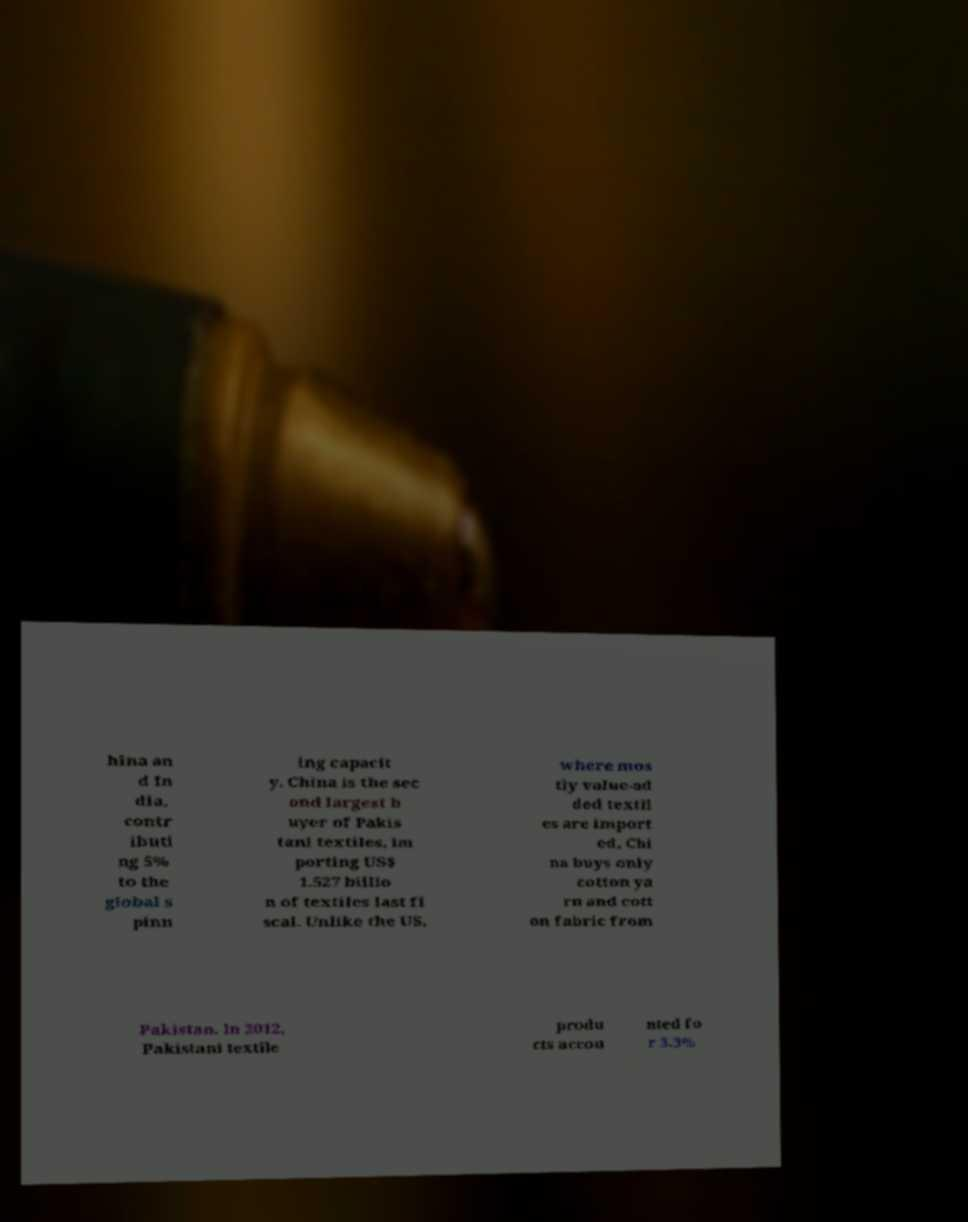There's text embedded in this image that I need extracted. Can you transcribe it verbatim? hina an d In dia, contr ibuti ng 5% to the global s pinn ing capacit y. China is the sec ond largest b uyer of Pakis tani textiles, im porting US$ 1.527 billio n of textiles last fi scal. Unlike the US, where mos tly value-ad ded textil es are import ed, Chi na buys only cotton ya rn and cott on fabric from Pakistan. In 2012, Pakistani textile produ cts accou nted fo r 3.3% 